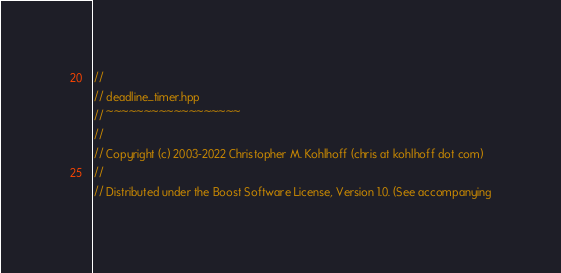Convert code to text. <code><loc_0><loc_0><loc_500><loc_500><_C++_>//
// deadline_timer.hpp
// ~~~~~~~~~~~~~~~~~~
//
// Copyright (c) 2003-2022 Christopher M. Kohlhoff (chris at kohlhoff dot com)
//
// Distributed under the Boost Software License, Version 1.0. (See accompanying</code> 